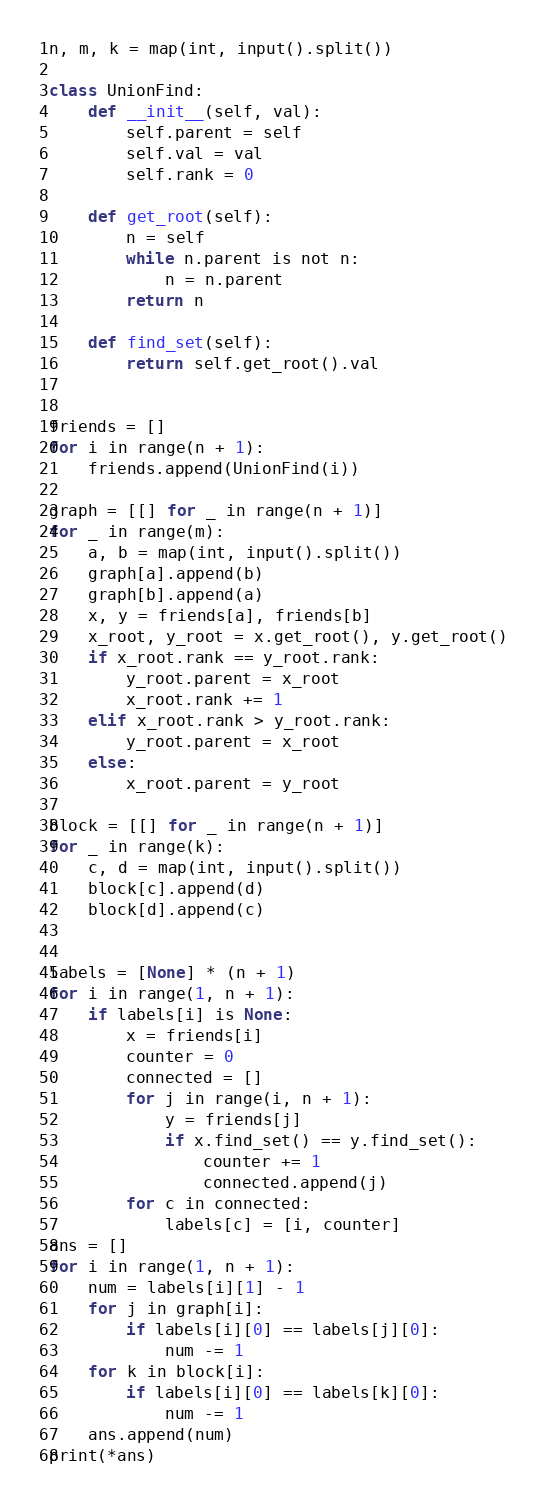Convert code to text. <code><loc_0><loc_0><loc_500><loc_500><_Python_>n, m, k = map(int, input().split())

class UnionFind:
    def __init__(self, val):
        self.parent = self
        self.val = val
        self.rank = 0

    def get_root(self):
        n = self
        while n.parent is not n:
            n = n.parent
        return n

    def find_set(self):
        return self.get_root().val


friends = []
for i in range(n + 1):
    friends.append(UnionFind(i))

graph = [[] for _ in range(n + 1)]
for _ in range(m):
    a, b = map(int, input().split())
    graph[a].append(b)
    graph[b].append(a)
    x, y = friends[a], friends[b]
    x_root, y_root = x.get_root(), y.get_root()
    if x_root.rank == y_root.rank:
        y_root.parent = x_root
        x_root.rank += 1
    elif x_root.rank > y_root.rank:
        y_root.parent = x_root
    else:
        x_root.parent = y_root

block = [[] for _ in range(n + 1)]
for _ in range(k):
    c, d = map(int, input().split())
    block[c].append(d)
    block[d].append(c)


labels = [None] * (n + 1)
for i in range(1, n + 1):
    if labels[i] is None:
        x = friends[i]
        counter = 0
        connected = []
        for j in range(i, n + 1):
            y = friends[j]
            if x.find_set() == y.find_set():
                counter += 1
                connected.append(j)
        for c in connected:
            labels[c] = [i, counter]
ans = []
for i in range(1, n + 1):
    num = labels[i][1] - 1
    for j in graph[i]:
        if labels[i][0] == labels[j][0]:
            num -= 1
    for k in block[i]:
        if labels[i][0] == labels[k][0]:
            num -= 1
    ans.append(num)
print(*ans)</code> 